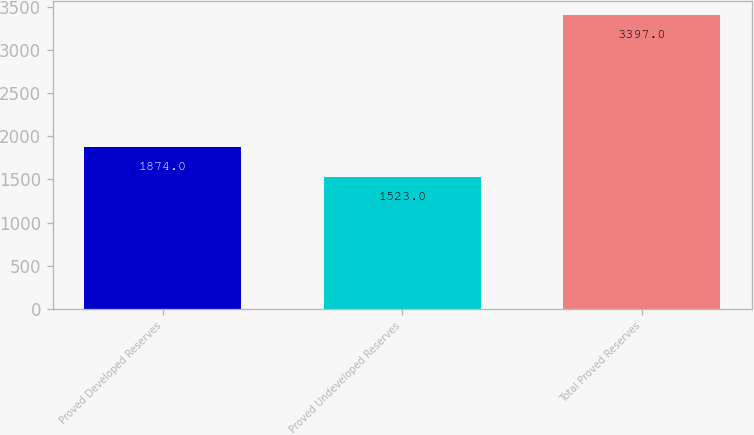Convert chart. <chart><loc_0><loc_0><loc_500><loc_500><bar_chart><fcel>Proved Developed Reserves<fcel>Proved Undeveloped Reserves<fcel>Total Proved Reserves<nl><fcel>1874<fcel>1523<fcel>3397<nl></chart> 